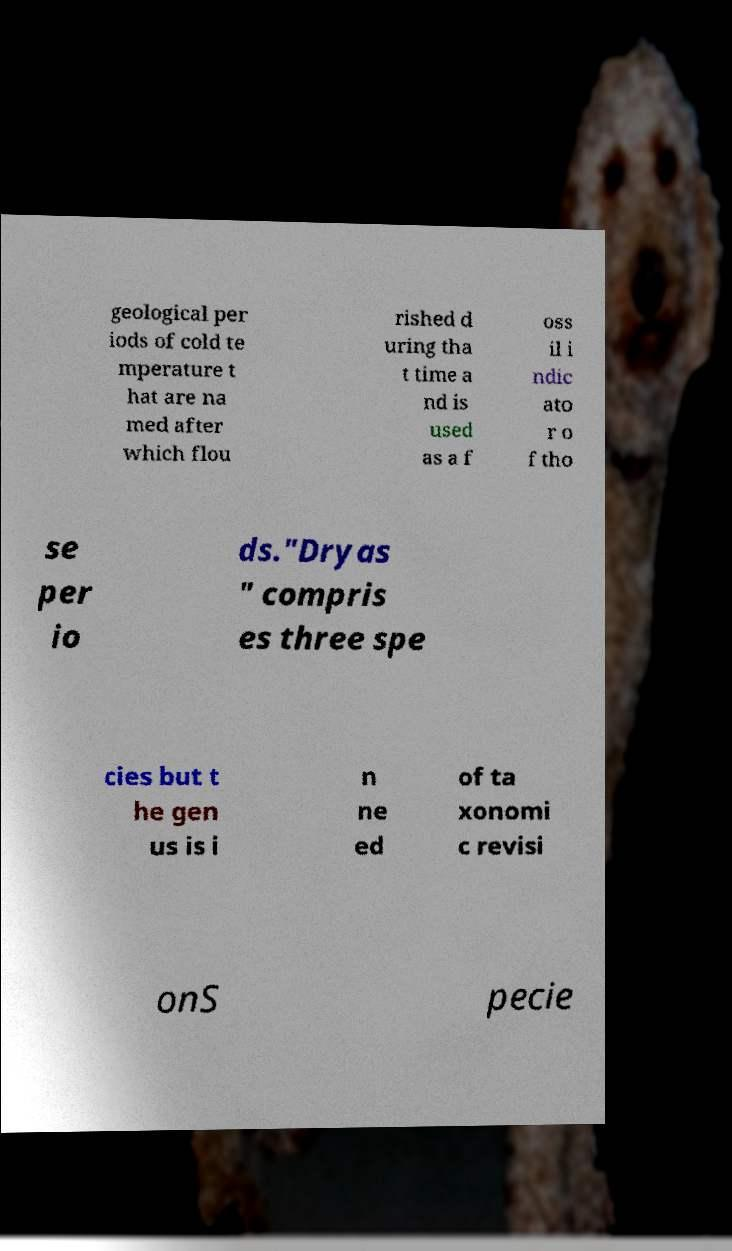What messages or text are displayed in this image? I need them in a readable, typed format. geological per iods of cold te mperature t hat are na med after which flou rished d uring tha t time a nd is used as a f oss il i ndic ato r o f tho se per io ds."Dryas " compris es three spe cies but t he gen us is i n ne ed of ta xonomi c revisi onS pecie 